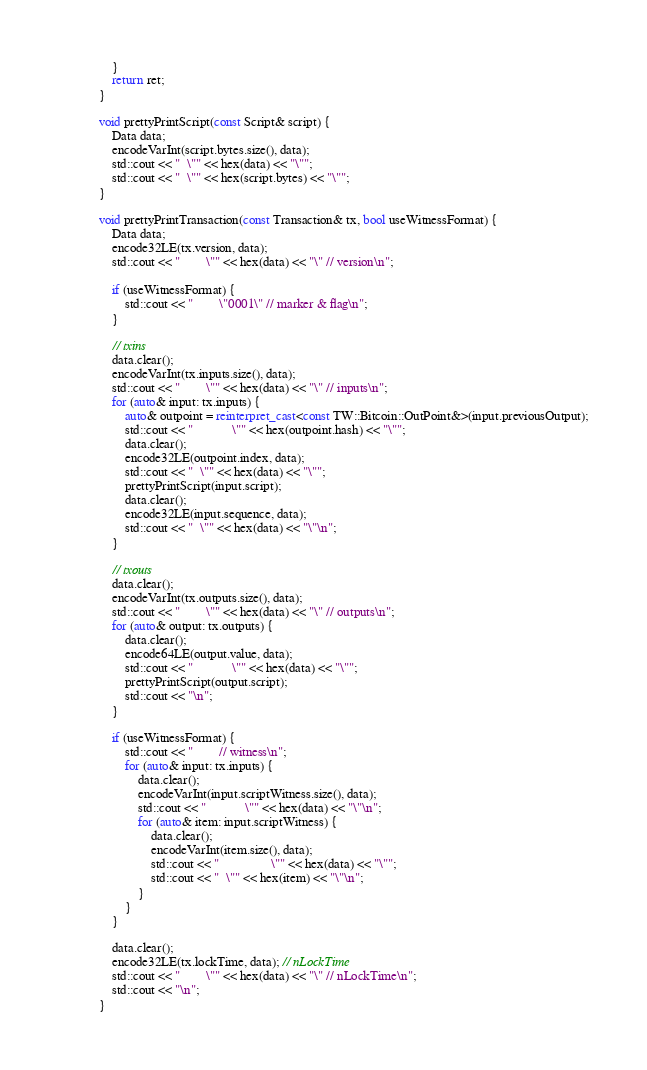<code> <loc_0><loc_0><loc_500><loc_500><_C++_>    }
    return ret;
}

void prettyPrintScript(const Script& script) {
    Data data;
    encodeVarInt(script.bytes.size(), data);
    std::cout << "  \"" << hex(data) << "\"";
    std::cout << "  \"" << hex(script.bytes) << "\"";
}

void prettyPrintTransaction(const Transaction& tx, bool useWitnessFormat) {
    Data data;
    encode32LE(tx.version, data);
    std::cout << "        \"" << hex(data) << "\" // version\n";

    if (useWitnessFormat) {
        std::cout << "        \"0001\" // marker & flag\n";
    }

    // txins
    data.clear();
    encodeVarInt(tx.inputs.size(), data);
    std::cout << "        \"" << hex(data) << "\" // inputs\n";
    for (auto& input: tx.inputs) {
        auto& outpoint = reinterpret_cast<const TW::Bitcoin::OutPoint&>(input.previousOutput);
        std::cout << "            \"" << hex(outpoint.hash) << "\"";
        data.clear();
        encode32LE(outpoint.index, data);
        std::cout << "  \"" << hex(data) << "\"";
        prettyPrintScript(input.script);
        data.clear();
        encode32LE(input.sequence, data);
        std::cout << "  \"" << hex(data) << "\"\n";
    }

    // txouts
    data.clear();
    encodeVarInt(tx.outputs.size(), data);
    std::cout << "        \"" << hex(data) << "\" // outputs\n";
    for (auto& output: tx.outputs) {
        data.clear();
        encode64LE(output.value, data);
        std::cout << "            \"" << hex(data) << "\"";
        prettyPrintScript(output.script);
        std::cout << "\n";
    }

    if (useWitnessFormat) {
        std::cout << "        // witness\n";
        for (auto& input: tx.inputs) {
            data.clear();
            encodeVarInt(input.scriptWitness.size(), data);
            std::cout << "            \"" << hex(data) << "\"\n";
            for (auto& item: input.scriptWitness) {
                data.clear();
                encodeVarInt(item.size(), data);
                std::cout << "                \"" << hex(data) << "\"";
                std::cout << "  \"" << hex(item) << "\"\n";
            }
        }
    }

    data.clear();
    encode32LE(tx.lockTime, data); // nLockTime
    std::cout << "        \"" << hex(data) << "\" // nLockTime\n";
    std::cout << "\n";
}
</code> 